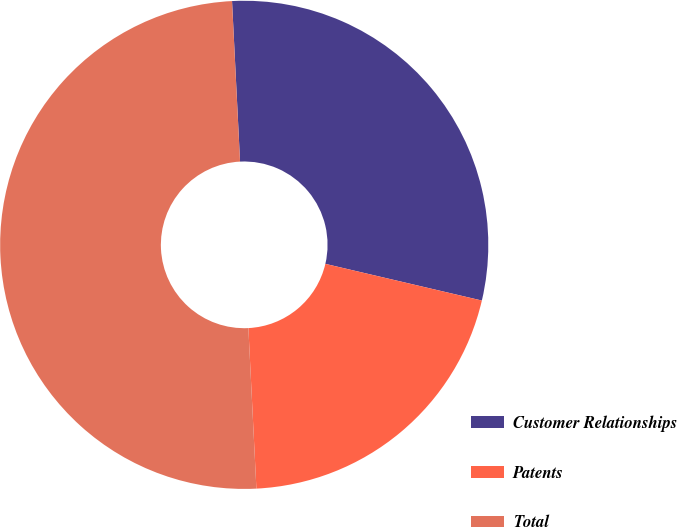Convert chart to OTSL. <chart><loc_0><loc_0><loc_500><loc_500><pie_chart><fcel>Customer Relationships<fcel>Patents<fcel>Total<nl><fcel>29.46%<fcel>20.54%<fcel>50.0%<nl></chart> 